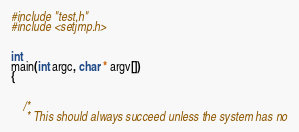<code> <loc_0><loc_0><loc_500><loc_500><_C_>
#include "test.h"
#include <setjmp.h>


int
main(int argc, char * argv[])
{


	/*
	 * This should always succeed unless the system has no</code> 